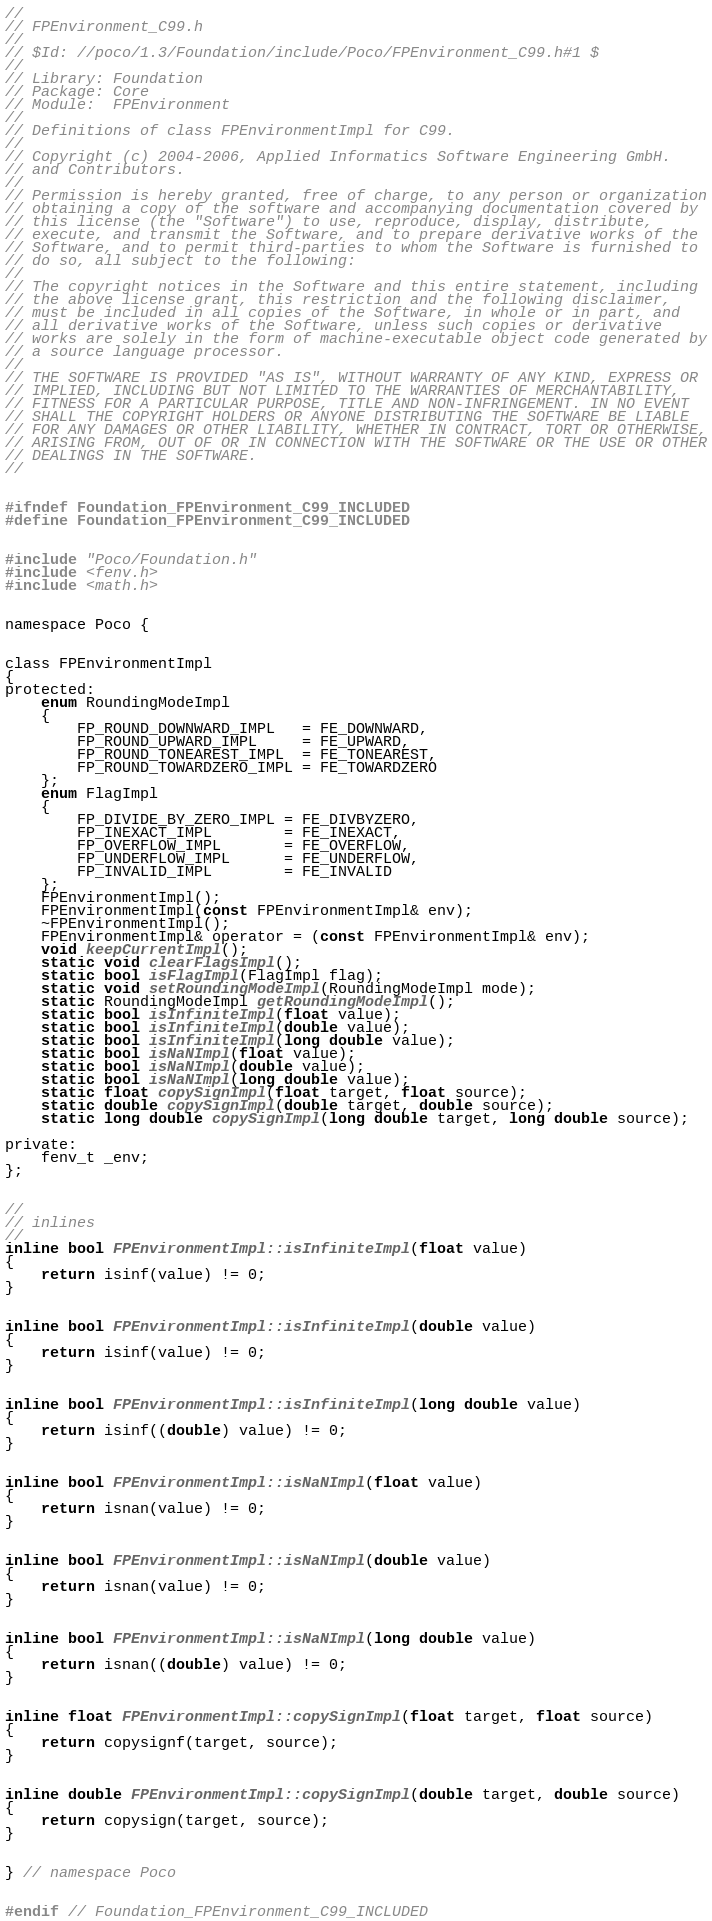<code> <loc_0><loc_0><loc_500><loc_500><_C_>//
// FPEnvironment_C99.h
//
// $Id: //poco/1.3/Foundation/include/Poco/FPEnvironment_C99.h#1 $
//
// Library: Foundation
// Package: Core
// Module:  FPEnvironment
//
// Definitions of class FPEnvironmentImpl for C99.
//
// Copyright (c) 2004-2006, Applied Informatics Software Engineering GmbH.
// and Contributors.
//
// Permission is hereby granted, free of charge, to any person or organization
// obtaining a copy of the software and accompanying documentation covered by
// this license (the "Software") to use, reproduce, display, distribute,
// execute, and transmit the Software, and to prepare derivative works of the
// Software, and to permit third-parties to whom the Software is furnished to
// do so, all subject to the following:
// 
// The copyright notices in the Software and this entire statement, including
// the above license grant, this restriction and the following disclaimer,
// must be included in all copies of the Software, in whole or in part, and
// all derivative works of the Software, unless such copies or derivative
// works are solely in the form of machine-executable object code generated by
// a source language processor.
// 
// THE SOFTWARE IS PROVIDED "AS IS", WITHOUT WARRANTY OF ANY KIND, EXPRESS OR
// IMPLIED, INCLUDING BUT NOT LIMITED TO THE WARRANTIES OF MERCHANTABILITY,
// FITNESS FOR A PARTICULAR PURPOSE, TITLE AND NON-INFRINGEMENT. IN NO EVENT
// SHALL THE COPYRIGHT HOLDERS OR ANYONE DISTRIBUTING THE SOFTWARE BE LIABLE
// FOR ANY DAMAGES OR OTHER LIABILITY, WHETHER IN CONTRACT, TORT OR OTHERWISE,
// ARISING FROM, OUT OF OR IN CONNECTION WITH THE SOFTWARE OR THE USE OR OTHER
// DEALINGS IN THE SOFTWARE.
//


#ifndef Foundation_FPEnvironment_C99_INCLUDED
#define Foundation_FPEnvironment_C99_INCLUDED


#include "Poco/Foundation.h"
#include <fenv.h>
#include <math.h>


namespace Poco {


class FPEnvironmentImpl
{
protected:
	enum RoundingModeImpl
	{
		FP_ROUND_DOWNWARD_IMPL   = FE_DOWNWARD,
		FP_ROUND_UPWARD_IMPL     = FE_UPWARD,
		FP_ROUND_TONEAREST_IMPL  = FE_TONEAREST,
		FP_ROUND_TOWARDZERO_IMPL = FE_TOWARDZERO
	};
	enum FlagImpl
	{
		FP_DIVIDE_BY_ZERO_IMPL = FE_DIVBYZERO,
		FP_INEXACT_IMPL        = FE_INEXACT,
		FP_OVERFLOW_IMPL       = FE_OVERFLOW,
		FP_UNDERFLOW_IMPL      = FE_UNDERFLOW,
		FP_INVALID_IMPL        = FE_INVALID
	};
	FPEnvironmentImpl();
	FPEnvironmentImpl(const FPEnvironmentImpl& env);
	~FPEnvironmentImpl();
	FPEnvironmentImpl& operator = (const FPEnvironmentImpl& env);
	void keepCurrentImpl();		
	static void clearFlagsImpl();
	static bool isFlagImpl(FlagImpl flag);	
	static void setRoundingModeImpl(RoundingModeImpl mode);
	static RoundingModeImpl getRoundingModeImpl();
	static bool isInfiniteImpl(float value);		
	static bool isInfiniteImpl(double value);
	static bool isInfiniteImpl(long double value);
	static bool isNaNImpl(float value);		
	static bool isNaNImpl(double value);
	static bool isNaNImpl(long double value);
	static float copySignImpl(float target, float source);		
	static double copySignImpl(double target, double source);
	static long double copySignImpl(long double target, long double source);

private:
	fenv_t _env;
};


//
// inlines
//
inline bool FPEnvironmentImpl::isInfiniteImpl(float value)
{
	return isinf(value) != 0;
}


inline bool FPEnvironmentImpl::isInfiniteImpl(double value)
{
	return isinf(value) != 0;
}


inline bool FPEnvironmentImpl::isInfiniteImpl(long double value)
{
	return isinf((double) value) != 0;
}


inline bool FPEnvironmentImpl::isNaNImpl(float value)
{
	return isnan(value) != 0;
}


inline bool FPEnvironmentImpl::isNaNImpl(double value)
{
	return isnan(value) != 0;
}


inline bool FPEnvironmentImpl::isNaNImpl(long double value)
{
	return isnan((double) value) != 0;
}


inline float FPEnvironmentImpl::copySignImpl(float target, float source)
{
	return copysignf(target, source);
}


inline double FPEnvironmentImpl::copySignImpl(double target, double source)
{
	return copysign(target, source);
}


} // namespace Poco


#endif // Foundation_FPEnvironment_C99_INCLUDED
</code> 